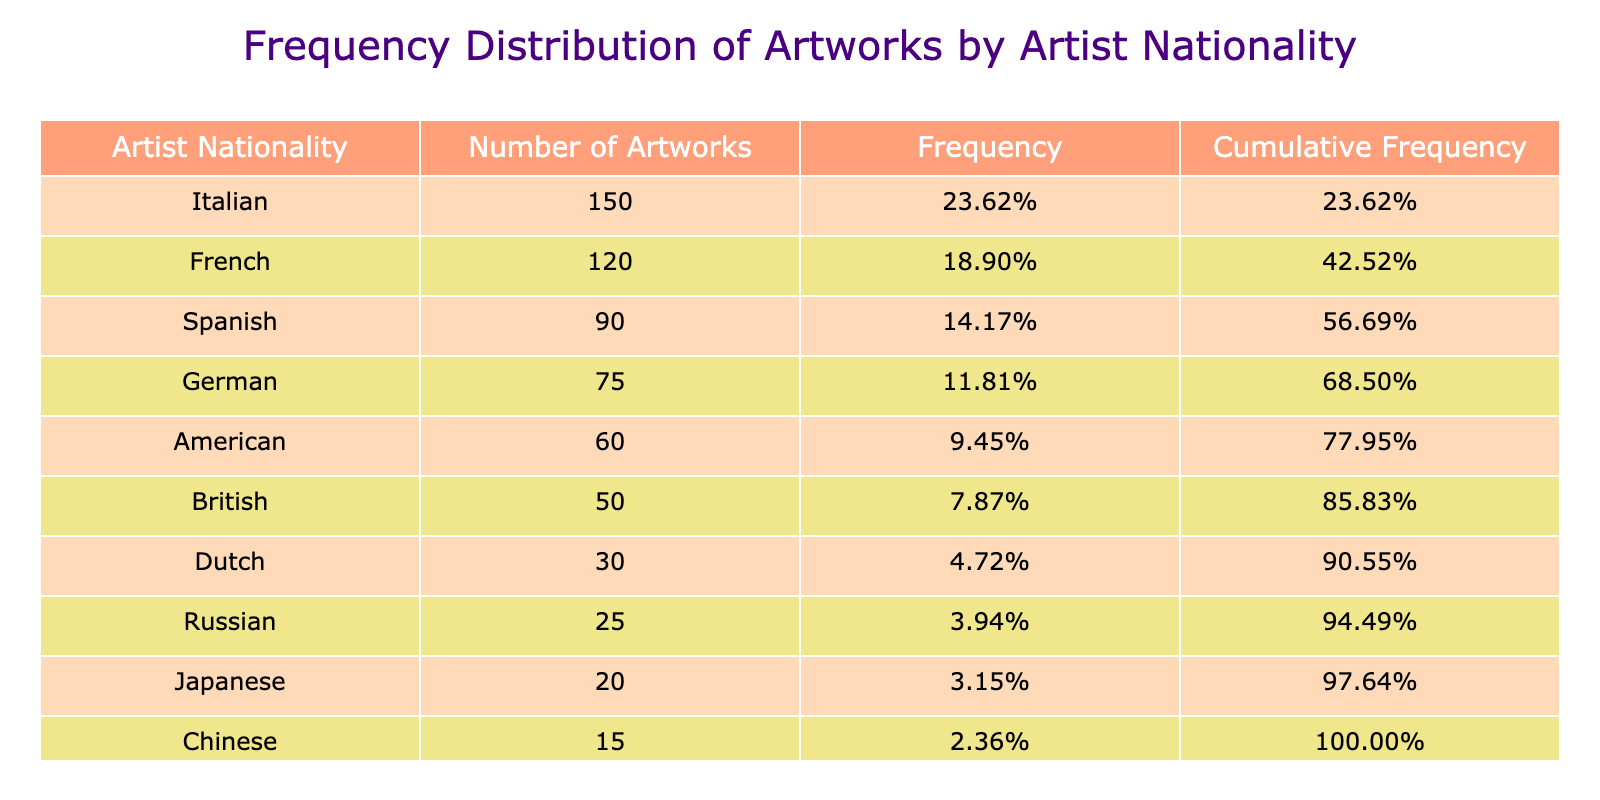What is the artist nationality with the highest number of artworks? By reviewing the table, I can see the "Number of Artworks" for each nationality. The highest value is 150, which corresponds to the Italian nationality.
Answer: Italian How many artworks are contributed by the American artist? The table shows that the "Number of Artworks" for American artists is 60.
Answer: 60 What is the cumulative frequency of artworks from French artists? Look at the "Cumulative Frequency" column in the table. The cumulative frequency for French artists is 71.43%, which includes their 120 artworks and those from all previous nationalities.
Answer: 71.43% Which nationality has the lowest representation in terms of artworks? Examining the "Number of Artworks" column, the nationality with the least number of artworks is Chinese, with 15 artworks.
Answer: Chinese Are there more Spanish artworks than British artworks? The number of artworks for Spanish artists is 90, while for British artists, it is 50. Since 90 is greater than 50, the statement is true.
Answer: Yes What is the combined total number of artworks from Italian and French artists? To find the total, I need to sum the "Number of Artworks" for Italian (150) and French (120) artists. This equals 150 + 120 = 270.
Answer: 270 What percentage of the total artworks does the Russian nationality represent? The total number of artworks is 1200 (150 + 120 + 90 + 75 + 60 + 50 + 30 + 25 + 20 + 15), and Russian artists have 25 artworks. To find the percentage, I divide 25 by 1200, which gives approximately 2.08%.
Answer: 2.08% Which nationalities have a cumulative frequency greater than or equal to 80%? I check the "Cumulative Frequency" column for nationalities that meet this criterion. The cumulative frequency for the Italian, French, Spanish, and German nationalities exceeds 80% (100%, 71.43%, 78.57%, and 83.57% respectively). I find that Italian, French, and Spanish surpass 80%.
Answer: Italian, French, Spanish Is the frequency of artworks from Dutch artists greater than those from Japanese artists? The frequency of artworks from Dutch artists is 30 (out of 1200), while from Japanese artists, it is 20. Since 30 is greater than 20, the answer is true.
Answer: Yes 